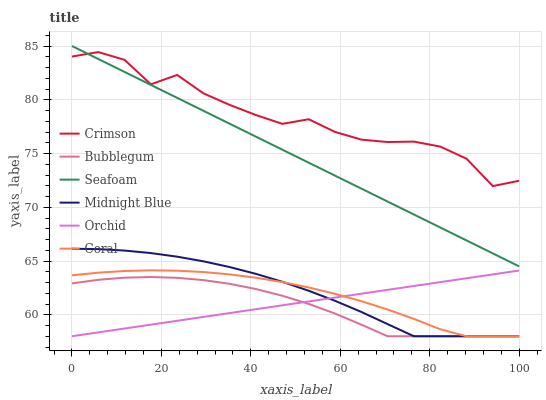Does Bubblegum have the minimum area under the curve?
Answer yes or no. Yes. Does Crimson have the maximum area under the curve?
Answer yes or no. Yes. Does Coral have the minimum area under the curve?
Answer yes or no. No. Does Coral have the maximum area under the curve?
Answer yes or no. No. Is Orchid the smoothest?
Answer yes or no. Yes. Is Crimson the roughest?
Answer yes or no. Yes. Is Coral the smoothest?
Answer yes or no. No. Is Coral the roughest?
Answer yes or no. No. Does Midnight Blue have the lowest value?
Answer yes or no. Yes. Does Seafoam have the lowest value?
Answer yes or no. No. Does Seafoam have the highest value?
Answer yes or no. Yes. Does Coral have the highest value?
Answer yes or no. No. Is Midnight Blue less than Crimson?
Answer yes or no. Yes. Is Seafoam greater than Midnight Blue?
Answer yes or no. Yes. Does Bubblegum intersect Midnight Blue?
Answer yes or no. Yes. Is Bubblegum less than Midnight Blue?
Answer yes or no. No. Is Bubblegum greater than Midnight Blue?
Answer yes or no. No. Does Midnight Blue intersect Crimson?
Answer yes or no. No. 